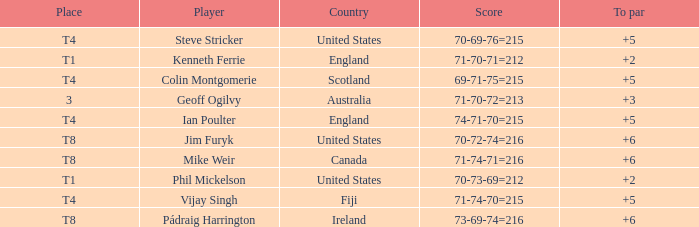What score to par did Mike Weir have? 6.0. 